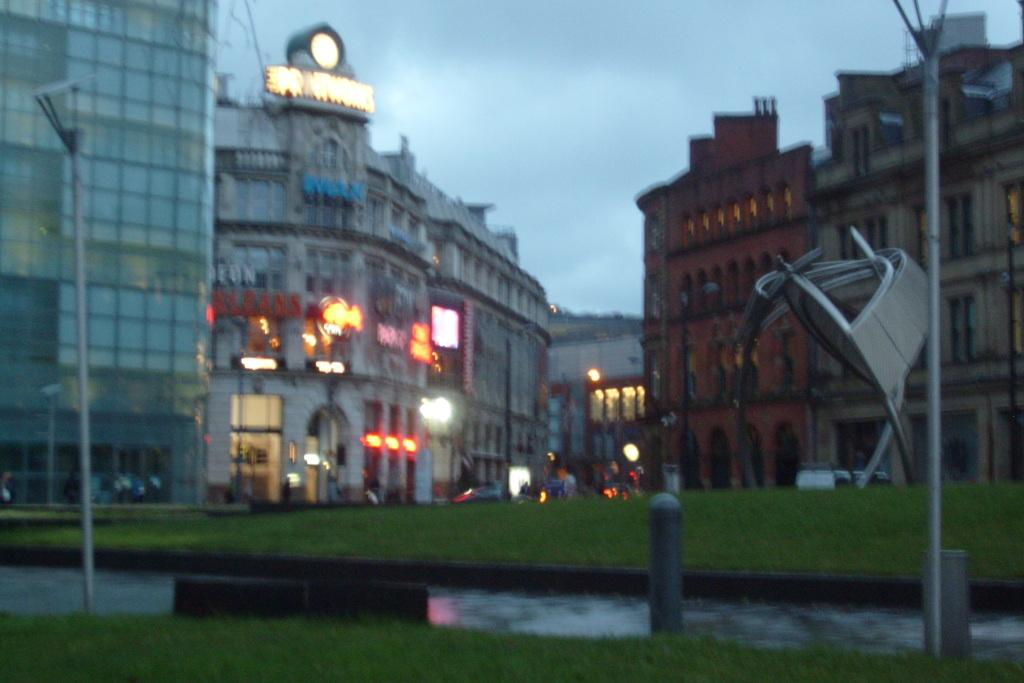What type of structures can be seen in the image? There are buildings in the image. What else can be seen in the image besides buildings? There are poles, text on at least one building, grass at the bottom of the image, water visible in the image, and vehicles in the image. What is visible at the top of the image? The sky is visible at the top of the image. Can you tell me how many glasses are on the bridge in the image? There is no bridge or glass present in the image. What type of park can be seen in the image? There is no park present in the image. 